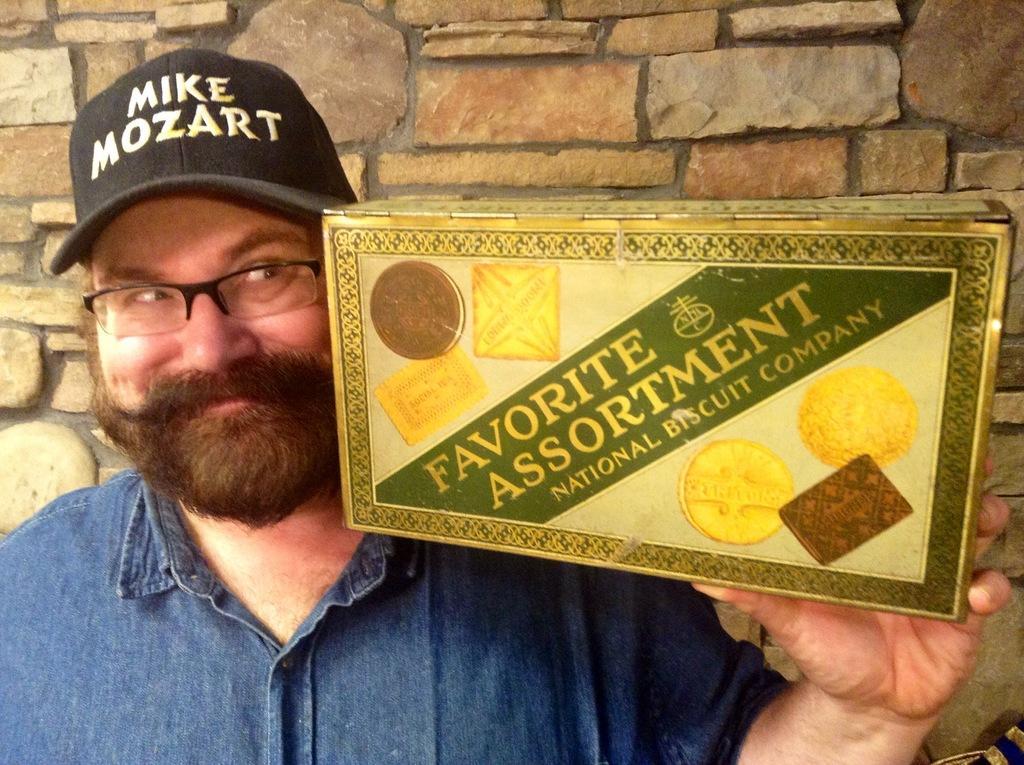Can you describe this image briefly? On the left side of the image we can see a man is standing and wearing spectacles, cap and holding a box. In the background of the image we can see the wall. 